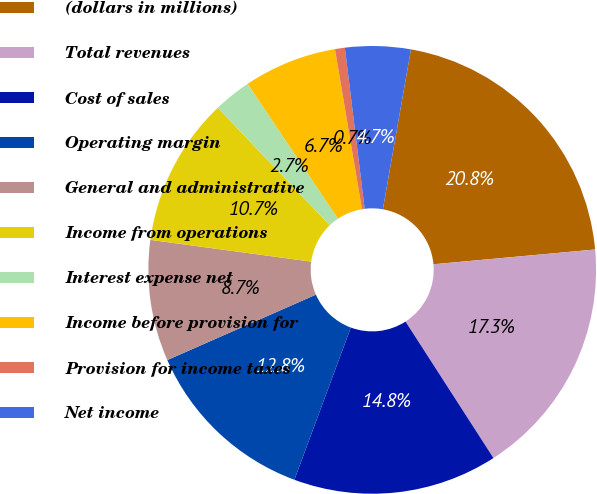Convert chart. <chart><loc_0><loc_0><loc_500><loc_500><pie_chart><fcel>(dollars in millions)<fcel>Total revenues<fcel>Cost of sales<fcel>Operating margin<fcel>General and administrative<fcel>Income from operations<fcel>Interest expense net<fcel>Income before provision for<fcel>Provision for income taxes<fcel>Net income<nl><fcel>20.78%<fcel>17.34%<fcel>14.76%<fcel>12.75%<fcel>8.74%<fcel>10.75%<fcel>2.72%<fcel>6.73%<fcel>0.71%<fcel>4.72%<nl></chart> 